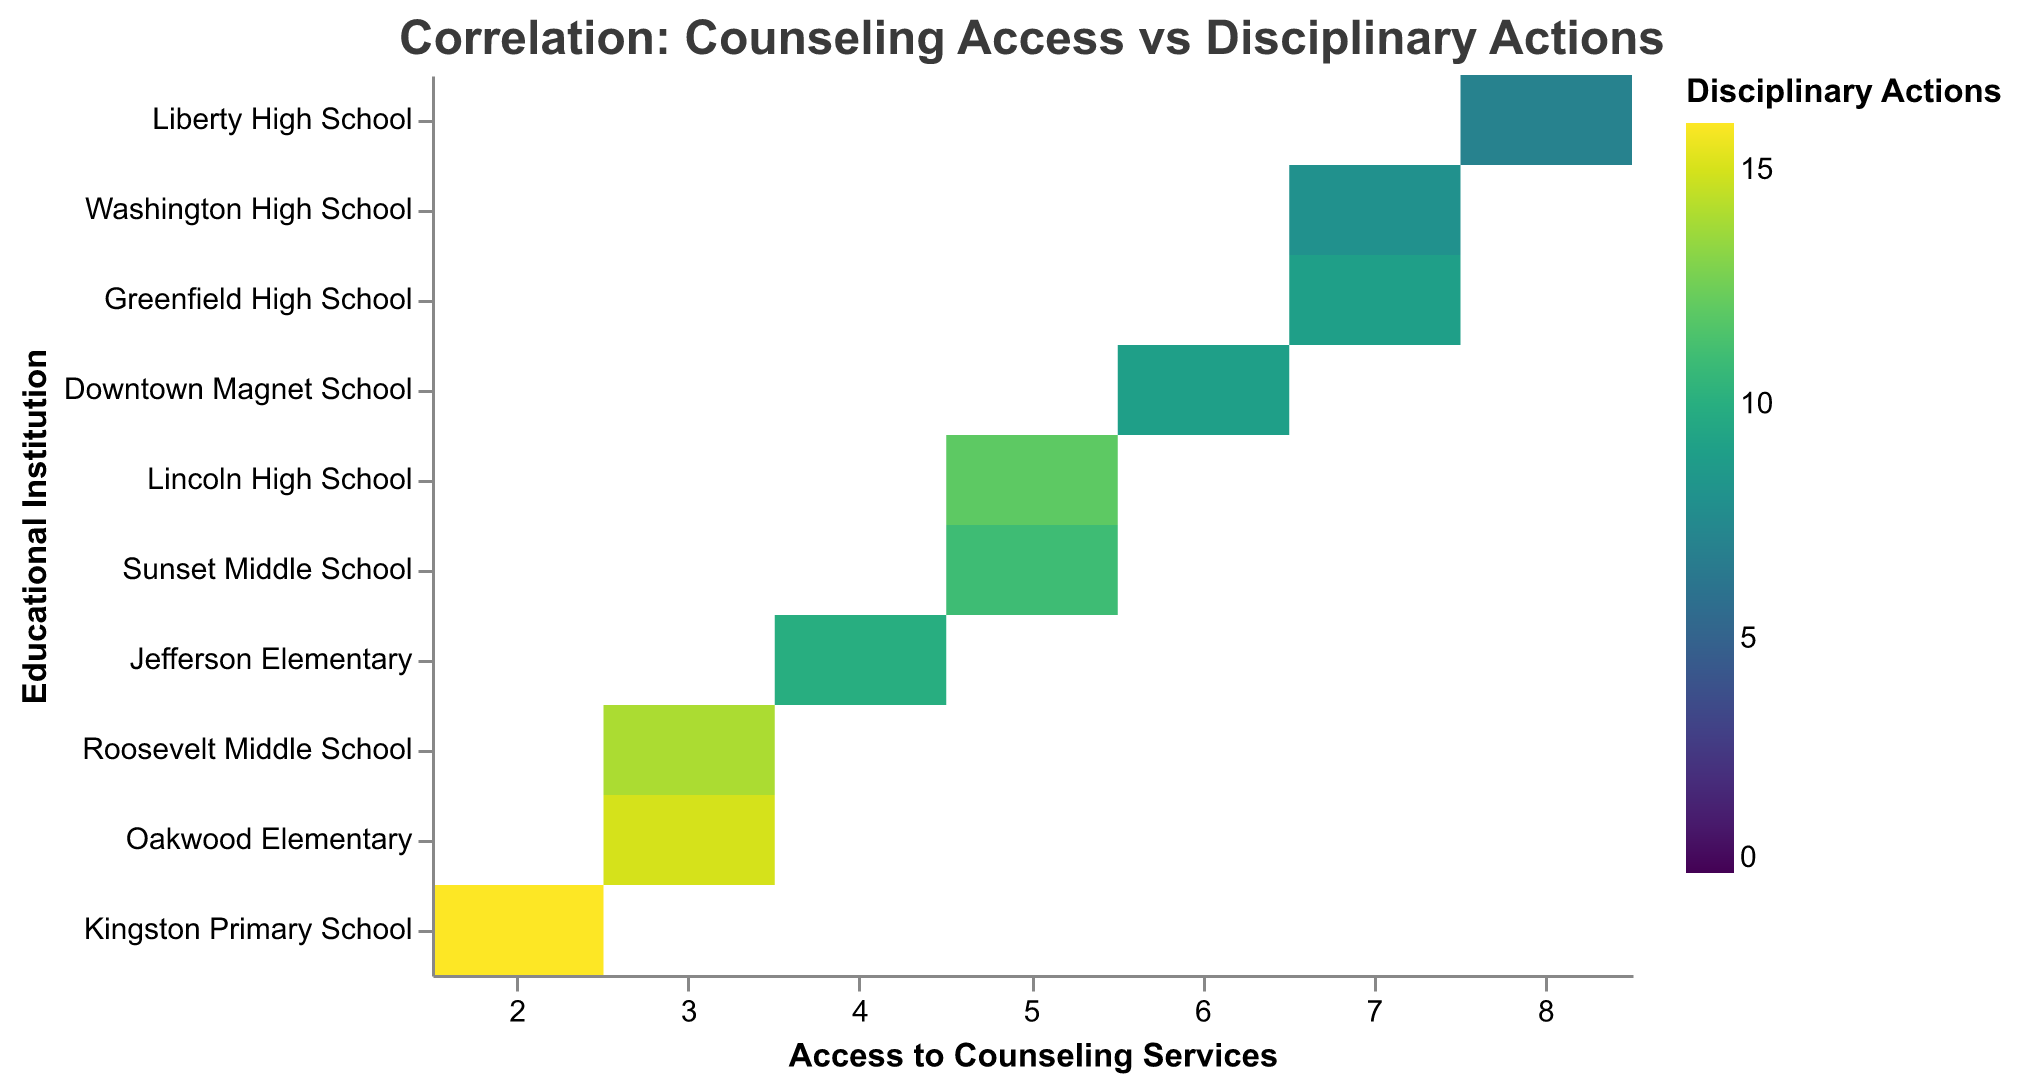What is the title of the heatmap? The title appears at the top of the figure in bold text.
Answer: Correlation: Counseling Access vs Disciplinary Actions Which institution provides the highest level of access to counseling services? Identify the institution on the y-axis corresponding to the highest value on the x-axis for Access to Counseling Services.
Answer: Liberty High School Which institution has the highest number of disciplinary actions? Look for the institution with the darkest color, as the color intensity represents the number of Disciplinary Actions.
Answer: Kingston Primary School How many institutions offer 7 hours per week of counseling services per 100 students? Count the number of data points (blocks) aligned with the x-axis value of 7 for Access to Counseling Services.
Answer: 2 Does Lincoln High School have more or fewer disciplinary actions than Jefferson Elementary? Compare the color intensity for Lincoln High School and Jefferson Elementary. A darker color indicates more disciplinary actions.
Answer: More What's the relationship between access to counseling services and disciplinary actions? Observe the overall trend in the figure; generally, lighter colors (fewer disciplinary actions) are seen with higher values of counseling services.
Answer: More access to counseling services tends to result in fewer disciplinary actions Which two institutions have the same level of counseling services but different numbers of disciplinary actions? Identify pairs of institutions on the y-axis that align with the same value on the x-axis but have different color intensities.
Answer: Lincoln High School and Sunset Middle School What is the average number of disciplinary actions for institutions providing 5 hours per week of counseling services per 100 students? Sum the disciplinary actions (colors) for institutions with 5 hours: Lincoln High School (12) and Sunset Middle School (11), then divide by the number of institutions (2). (12 + 11) / 2 = 11.5
Answer: 11.5 Does Liberty High School have lower disciplinary actions than Downtown Magnet School? Compare the color intensity for Liberty High School and Downtown Magnet School. A lighter color indicates fewer disciplinary actions.
Answer: Yes What is the range of disciplinary actions across all institutions? Identify the lightest and darkest colors corresponding to the minimum and maximum disciplinary actions. The range is from the lightest (7) to the darkest (16). 16 - 7 = 9
Answer: 9 